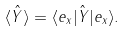Convert formula to latex. <formula><loc_0><loc_0><loc_500><loc_500>\langle \hat { Y } \rangle = \langle e _ { x } | \hat { Y } | e _ { x } \rangle .</formula> 